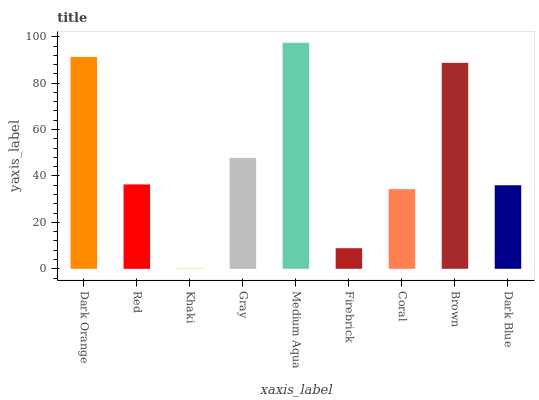Is Red the minimum?
Answer yes or no. No. Is Red the maximum?
Answer yes or no. No. Is Dark Orange greater than Red?
Answer yes or no. Yes. Is Red less than Dark Orange?
Answer yes or no. Yes. Is Red greater than Dark Orange?
Answer yes or no. No. Is Dark Orange less than Red?
Answer yes or no. No. Is Red the high median?
Answer yes or no. Yes. Is Red the low median?
Answer yes or no. Yes. Is Gray the high median?
Answer yes or no. No. Is Firebrick the low median?
Answer yes or no. No. 